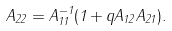<formula> <loc_0><loc_0><loc_500><loc_500>A _ { 2 2 } = A ^ { - 1 } _ { 1 1 } ( 1 + q A _ { 1 2 } A _ { 2 1 } ) .</formula> 